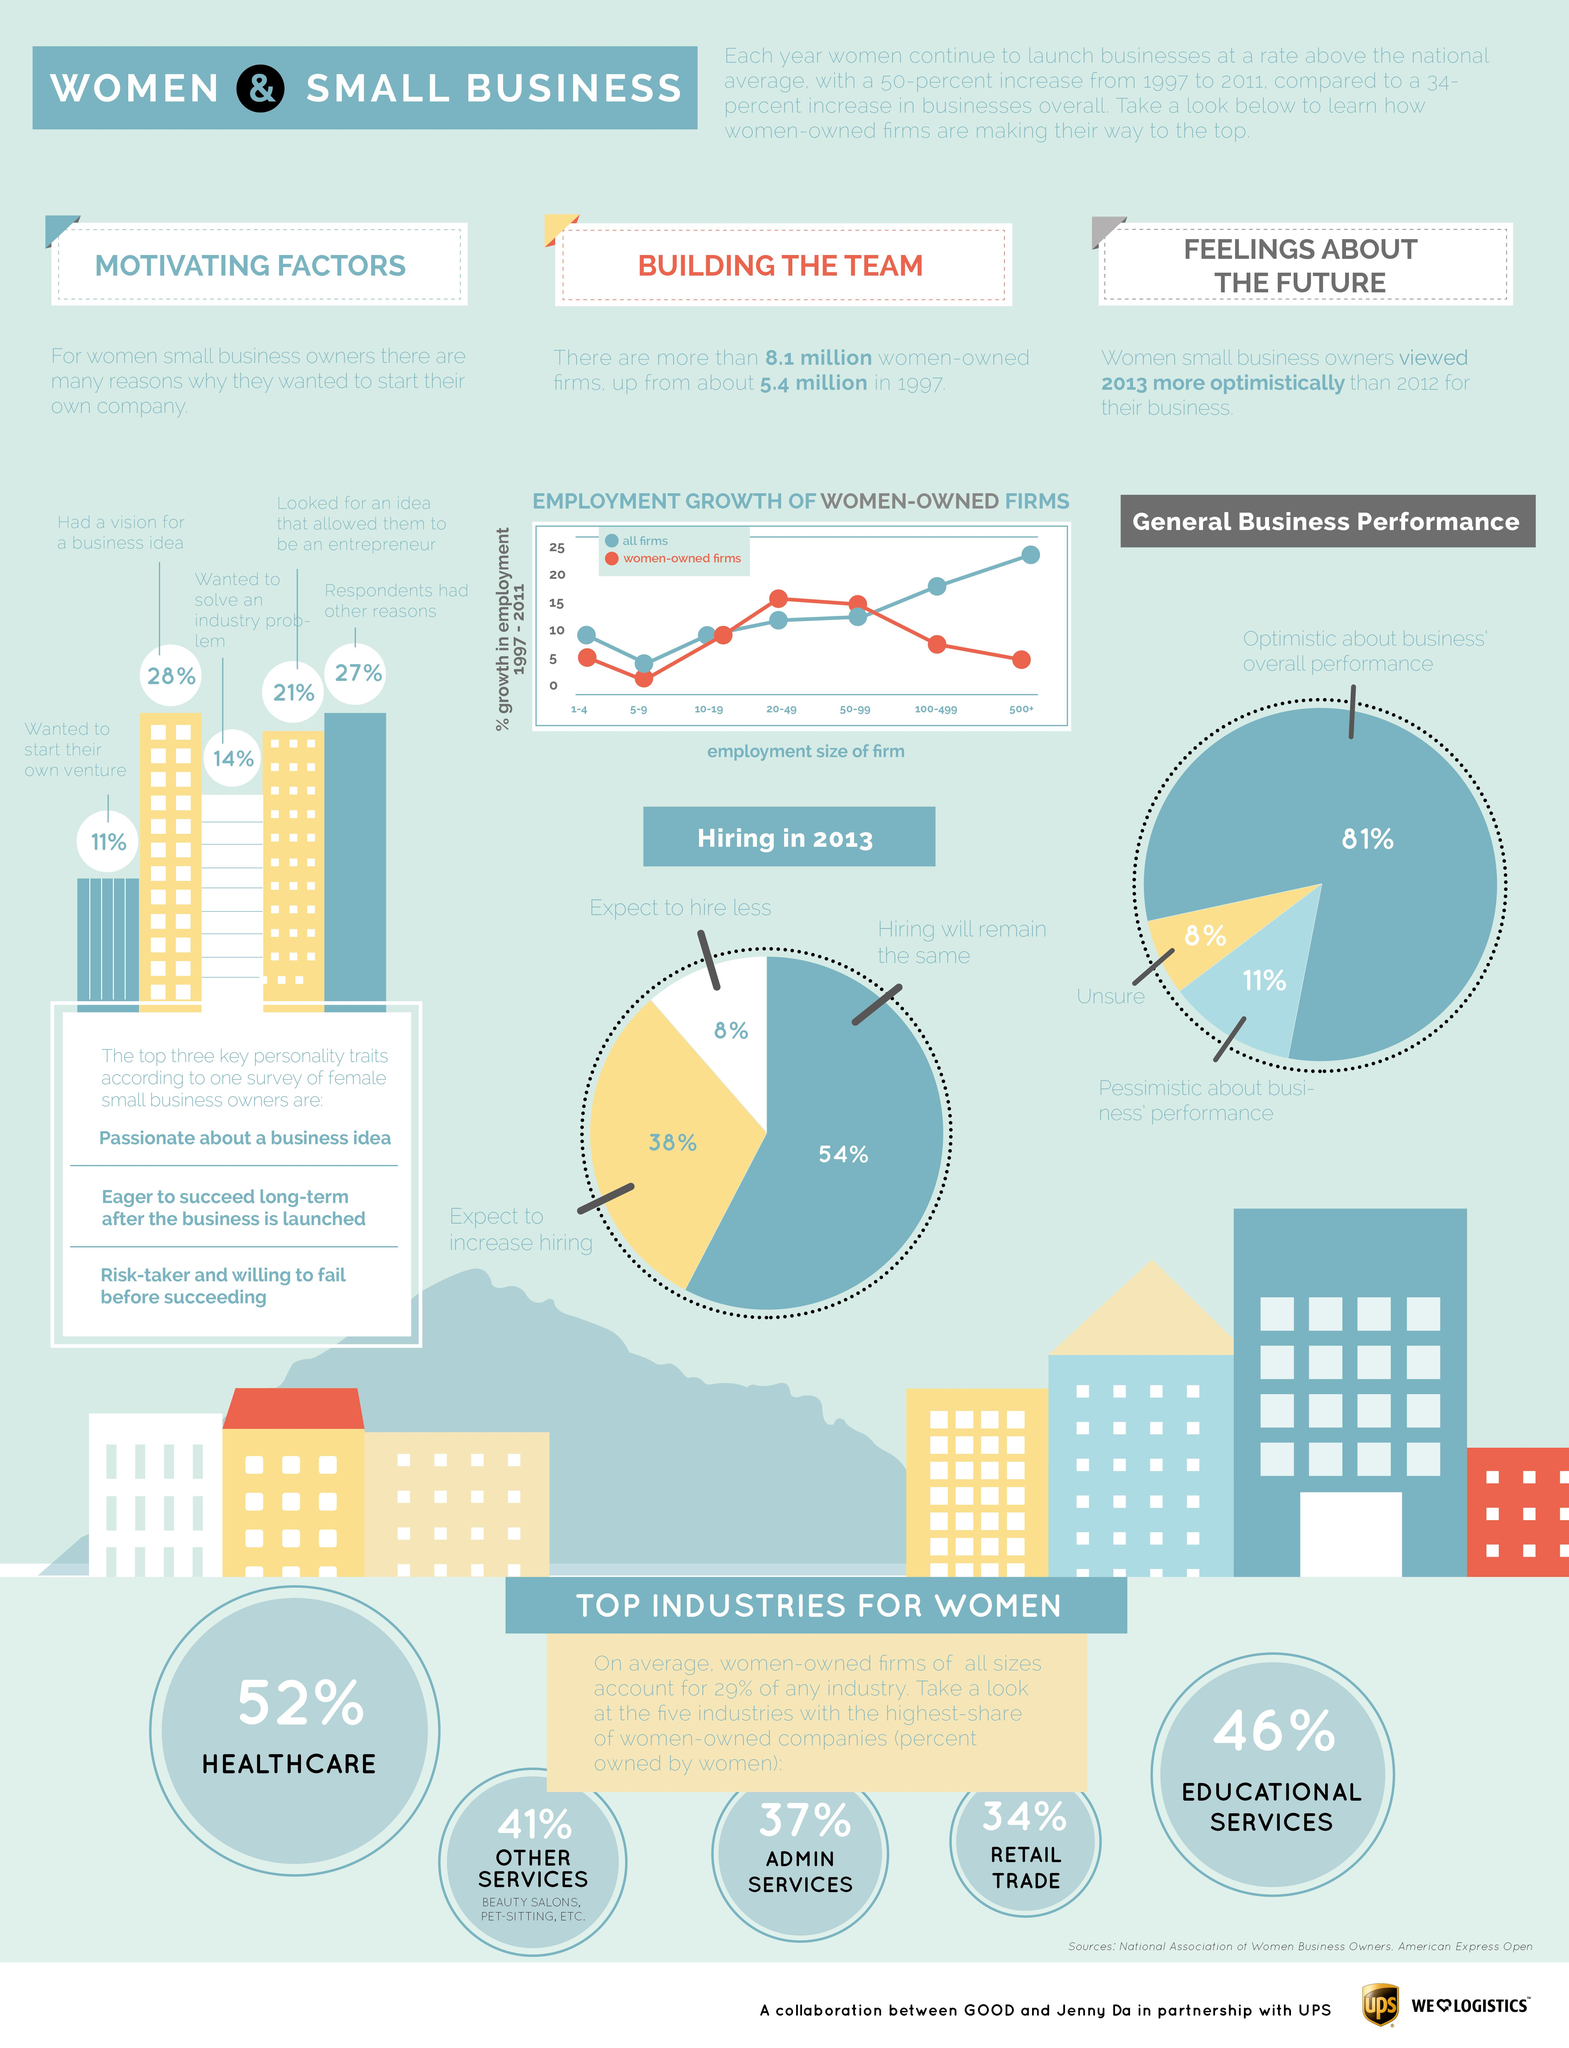Identify some key points in this picture. Female business owners are known for having a strong and passionate personality trait that drives them to pursue their business ideas with determination and dedication. In 2013, 54% of women-owned firms reported that their hiring levels would remain the same. 14% of women business owners were motivated to start their own companies in order to solve industry-specific problems they identified. The second highest percentage of women-owned companies is in the educational services industry. According to recent data, 52% of companies in the healthcare sector are owned by women. 